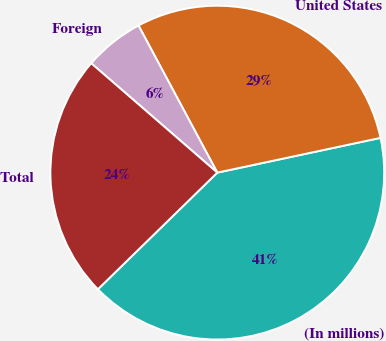Convert chart to OTSL. <chart><loc_0><loc_0><loc_500><loc_500><pie_chart><fcel>(In millions)<fcel>United States<fcel>Foreign<fcel>Total<nl><fcel>41.03%<fcel>29.49%<fcel>5.8%<fcel>23.69%<nl></chart> 